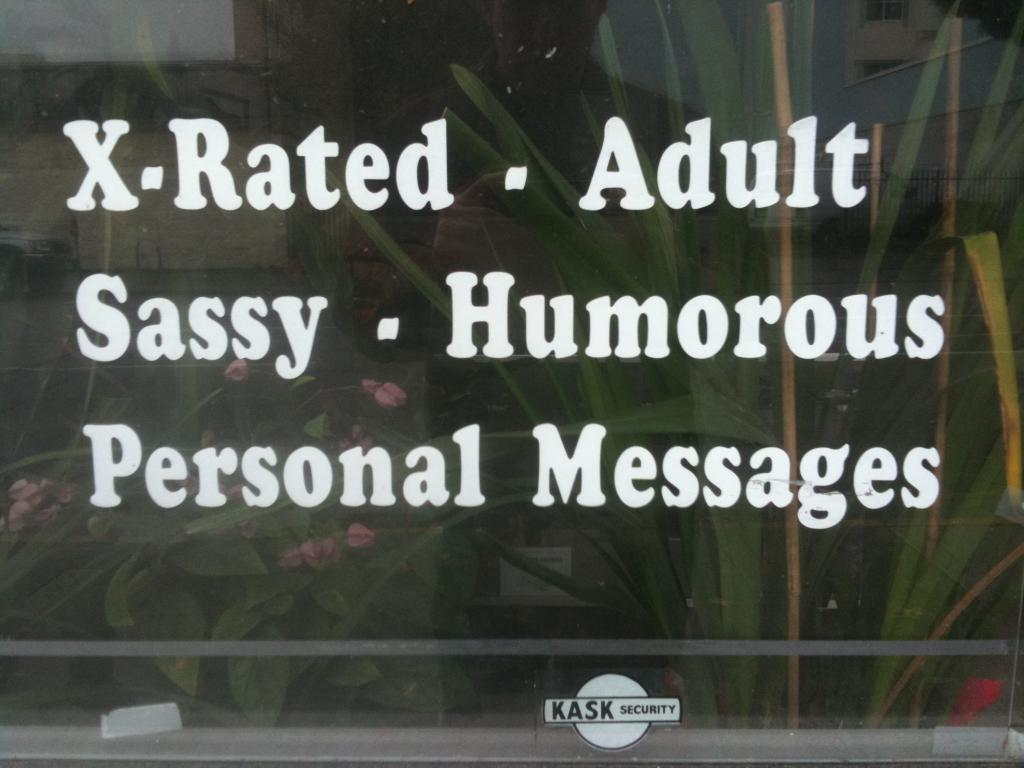What is located in the foreground of the image? There is text in the foreground of the image. What can be seen behind the text? There are plants visible behind the text. How many agreements were made on the island depicted in the image? There is no island or any reference to agreements in the image; it only features text and plants. 